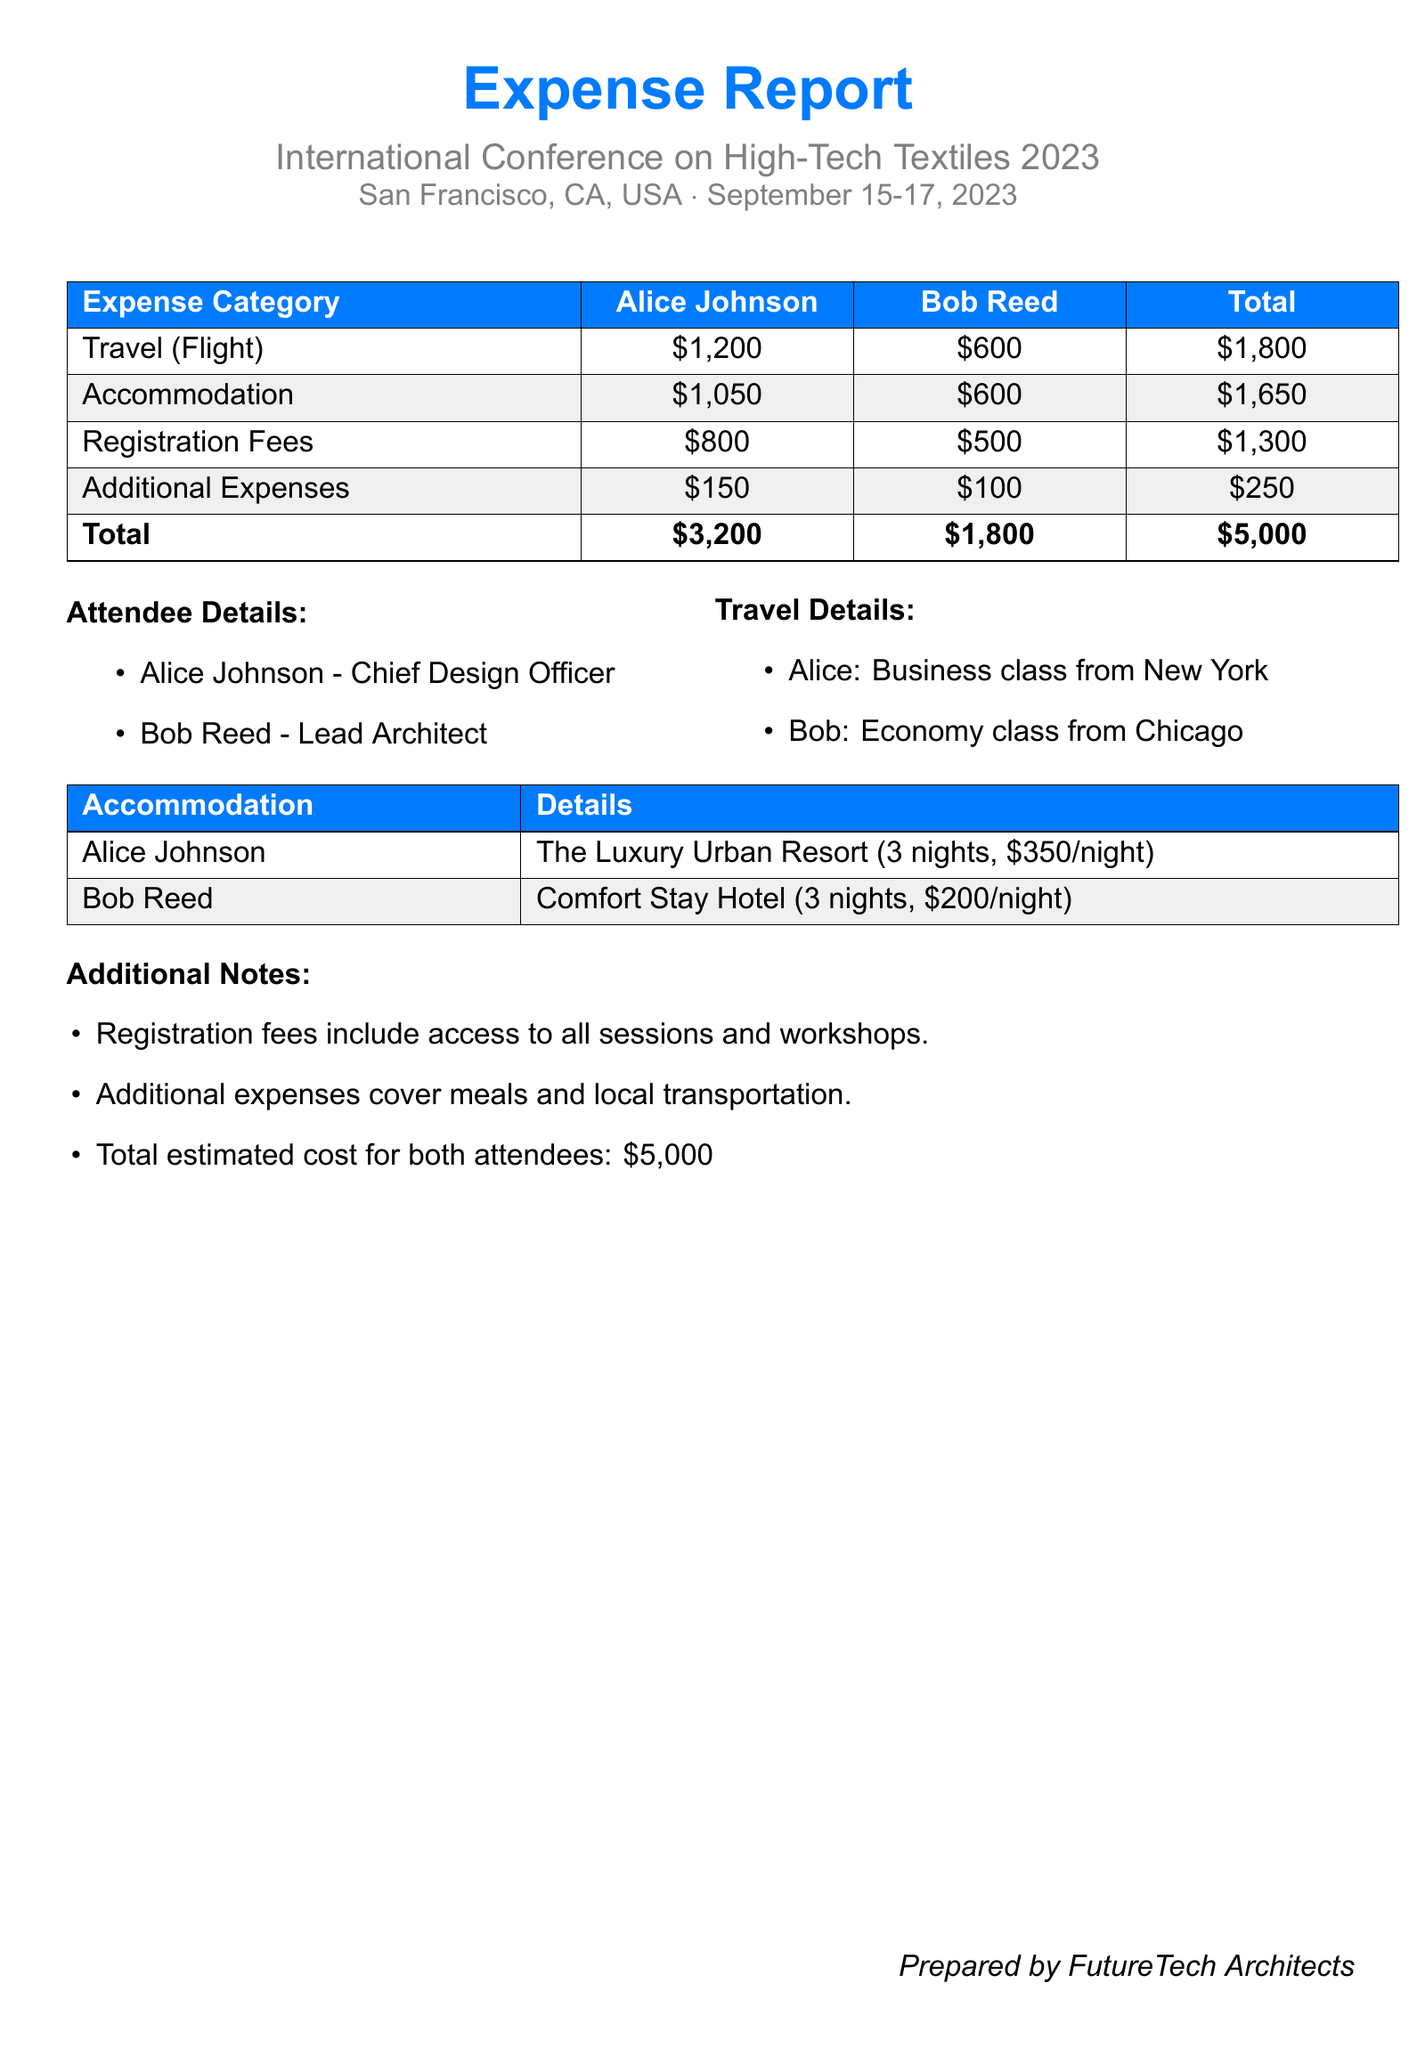What is the total expense for Alice Johnson? The total expense for Alice Johnson is found in the total row of the expense table, which states her total as $3,200.
Answer: $3,200 What is the total expense for Bob Reed? The total expense for Bob Reed is referenced in the total row of the expense table, showing his total as $1,800.
Answer: $1,800 What was the cost of accommodation for Alice Johnson? Alice Johnson's accommodation cost is listed as $1,050 in the expense table.
Answer: $1,050 How many nights did Alice Johnson stay at the hotel? The accommodation details for Alice Johnson mention that she stayed for 3 nights.
Answer: 3 nights What type of flight did Alice take? The travel details indicate that Alice took a business class flight.
Answer: Business class What is the total estimated cost for both attendees? The document explicitly states that the total estimated cost for both attendees is $5,000 in the additional notes section.
Answer: $5,000 What was the registration fee for Bob Reed? The registration fees table shows Bob Reed's registration fee as $500.
Answer: $500 Which hotel did Bob Reed stay in? Bob Reed's accommodation details specify he stayed at Comfort Stay Hotel.
Answer: Comfort Stay Hotel What are the dates of the conference? The document mentions that the conference took place from September 15 to September 17, 2023.
Answer: September 15-17, 2023 